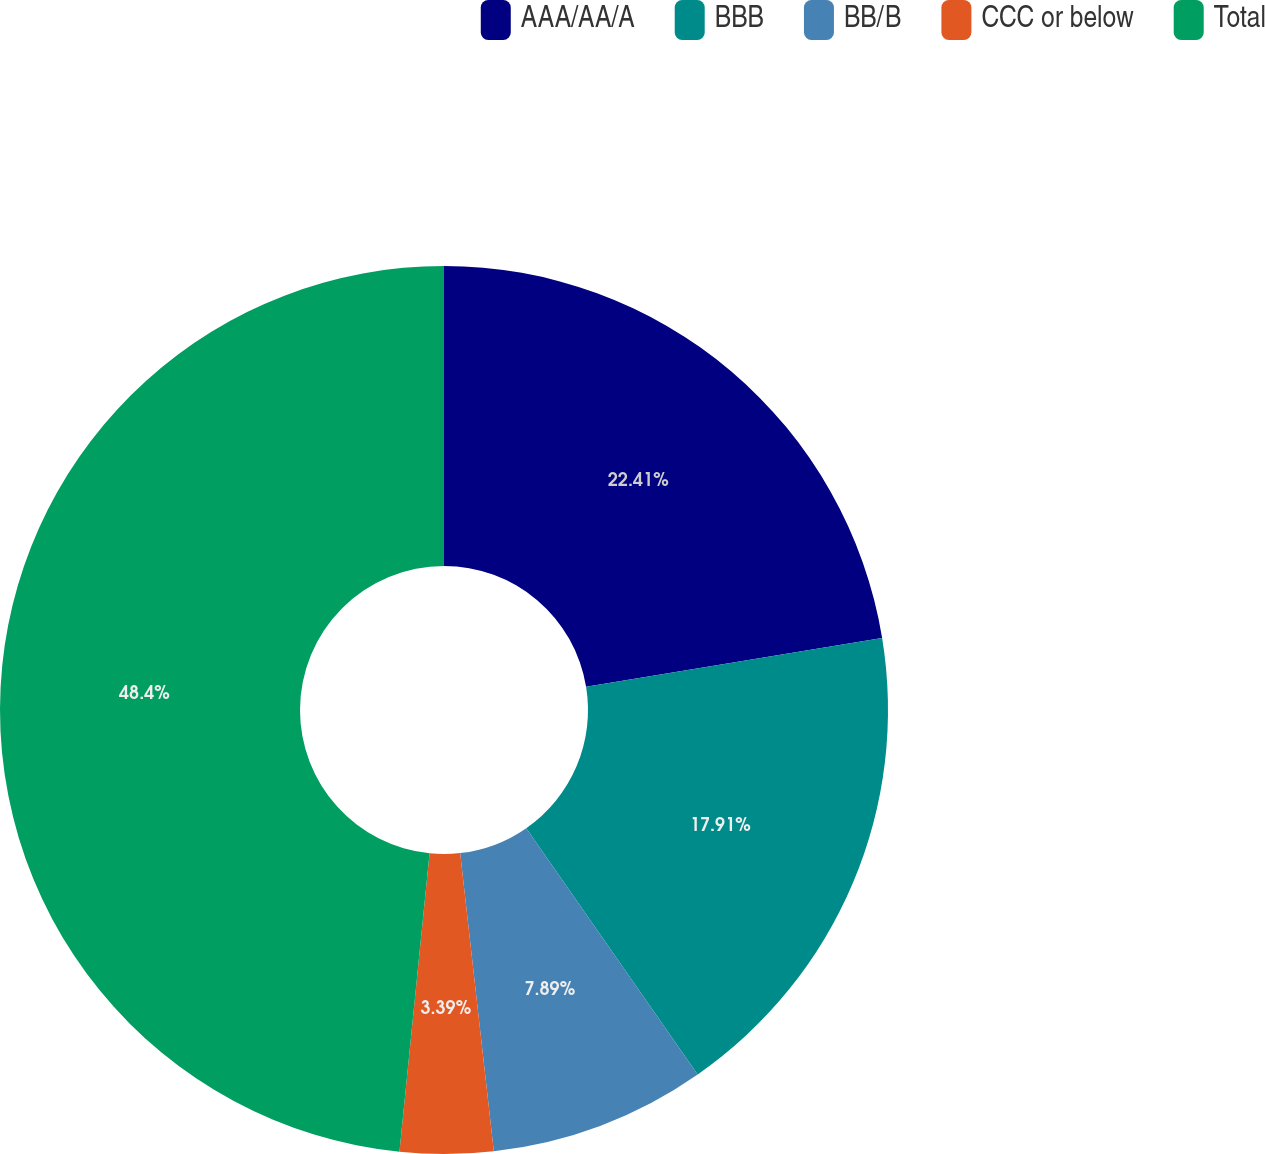Convert chart. <chart><loc_0><loc_0><loc_500><loc_500><pie_chart><fcel>AAA/AA/A<fcel>BBB<fcel>BB/B<fcel>CCC or below<fcel>Total<nl><fcel>22.41%<fcel>17.91%<fcel>7.89%<fcel>3.39%<fcel>48.4%<nl></chart> 